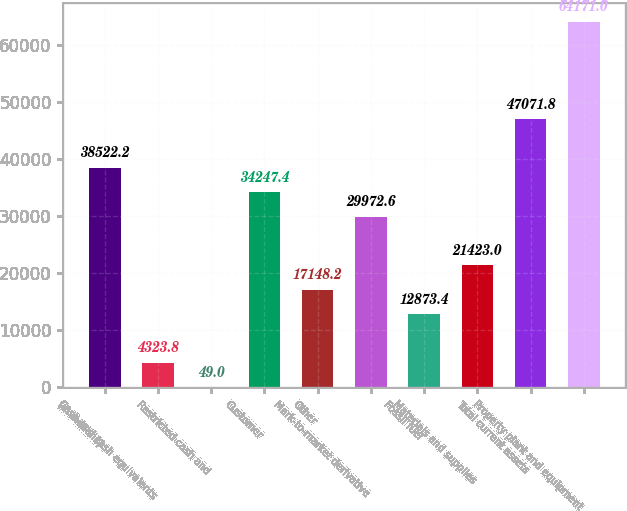Convert chart. <chart><loc_0><loc_0><loc_500><loc_500><bar_chart><fcel>(in millions)<fcel>Cash and cash equivalents<fcel>Restricted cash and<fcel>Customer<fcel>Other<fcel>Mark-to-market derivative<fcel>Fossil fuel<fcel>Materials and supplies<fcel>Total current assets<fcel>Property plant and equipment<nl><fcel>38522.2<fcel>4323.8<fcel>49<fcel>34247.4<fcel>17148.2<fcel>29972.6<fcel>12873.4<fcel>21423<fcel>47071.8<fcel>64171<nl></chart> 